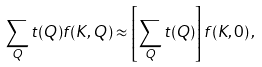Convert formula to latex. <formula><loc_0><loc_0><loc_500><loc_500>\sum _ { Q } t ( Q ) f ( K , Q ) \approx \left [ \sum _ { Q } t ( Q ) \right ] f ( K , 0 ) \, ,</formula> 